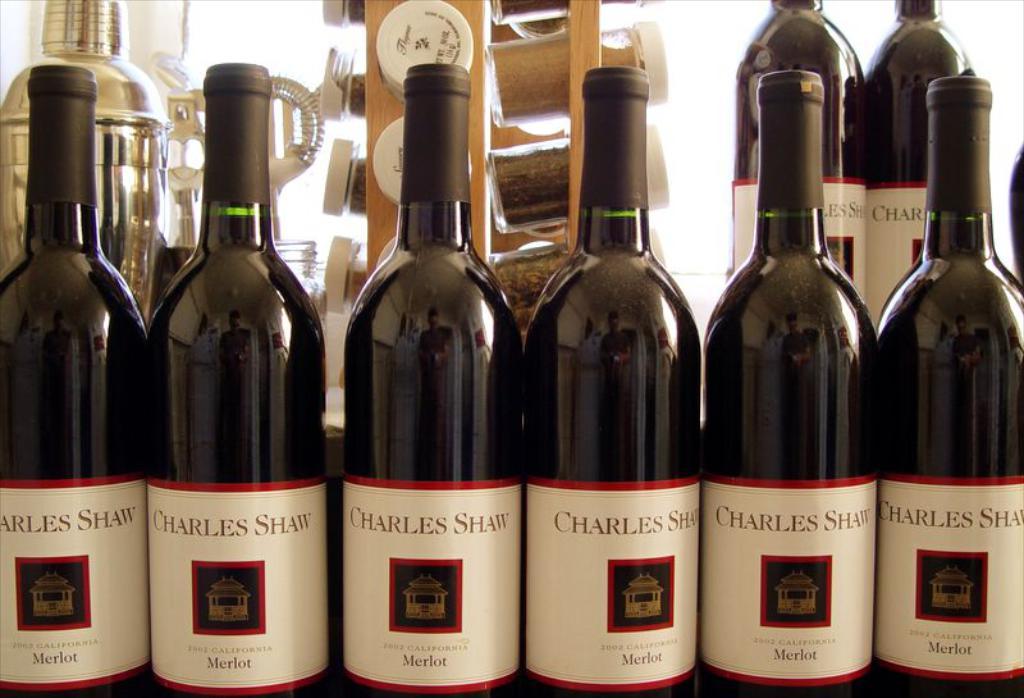What state is written on the labels?
Provide a short and direct response. California. 